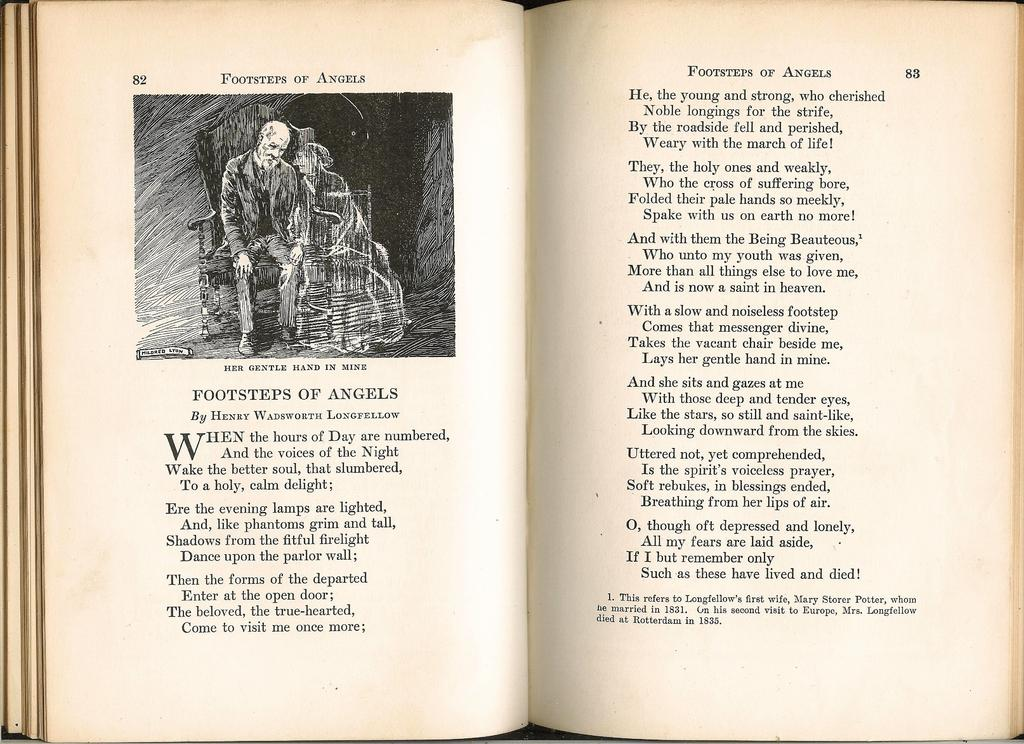<image>
Write a terse but informative summary of the picture. An older book features the poem "Footsteps of Angels" on page 82 with a lithograph drawing. 